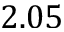<formula> <loc_0><loc_0><loc_500><loc_500>2 . 0 5</formula> 